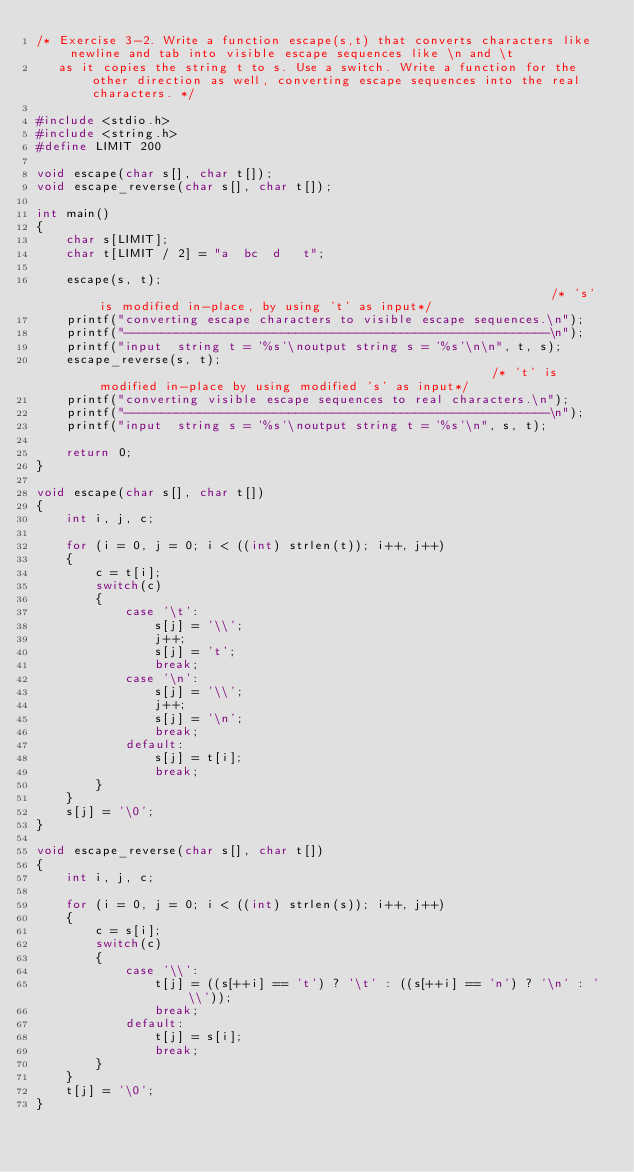Convert code to text. <code><loc_0><loc_0><loc_500><loc_500><_C_>/* Exercise 3-2. Write a function escape(s,t) that converts characters like newline and tab into visible escape sequences like \n and \t 
   as it copies the string t to s. Use a switch. Write a function for the other direction as well, converting escape sequences into the real characters. */

#include <stdio.h>
#include <string.h>
#define LIMIT 200

void escape(char s[], char t[]);
void escape_reverse(char s[], char t[]);

int main()
{     
    char s[LIMIT];
    char t[LIMIT / 2] = "a	bc	d	t";
    
    escape(s, t);                                                              /* 's' is modified in-place, by using 't' as input*/
    printf("converting escape characters to visible escape sequences.\n");
    printf("---------------------------------------------------------\n");
    printf("input  string t = '%s'\noutput string s = '%s'\n\n", t, s);
    escape_reverse(s, t);                                                      /* 't' is modified in-place by using modified 's' as input*/
    printf("converting visible escape sequences to real characters.\n");
    printf("---------------------------------------------------------\n");   
    printf("input  string s = '%s'\noutput string t = '%s'\n", s, t);
    
    return 0;
}

void escape(char s[], char t[])
{
    int i, j, c;
    
    for (i = 0, j = 0; i < ((int) strlen(t)); i++, j++)
    {
        c = t[i];
        switch(c)
        {
            case '\t':
                s[j] = '\\';
                j++;
                s[j] = 't';
                break;
            case '\n':
                s[j] = '\\';  
                j++;
                s[j] = '\n';  
                break;            
            default:
                s[j] = t[i];
                break;
        }
    }
    s[j] = '\0';
}

void escape_reverse(char s[], char t[])
{
    int i, j, c;
    
    for (i = 0, j = 0; i < ((int) strlen(s)); i++, j++)
    {
        c = s[i];
        switch(c)
        {
            case '\\':
                t[j] = ((s[++i] == 't') ? '\t' : ((s[++i] == 'n') ? '\n' : '\\'));
                break;             
            default:
                t[j] = s[i];
                break;
        }
    }
    t[j] = '\0';    
}
</code> 